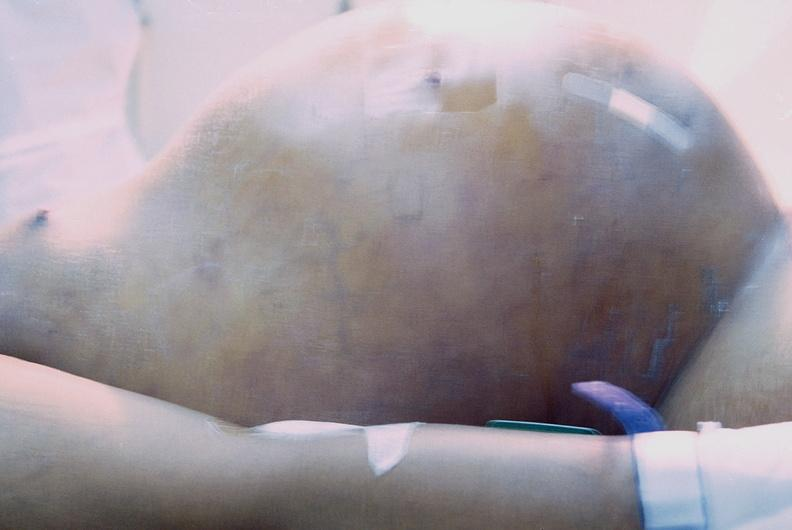what is present?
Answer the question using a single word or phrase. Abdomen 